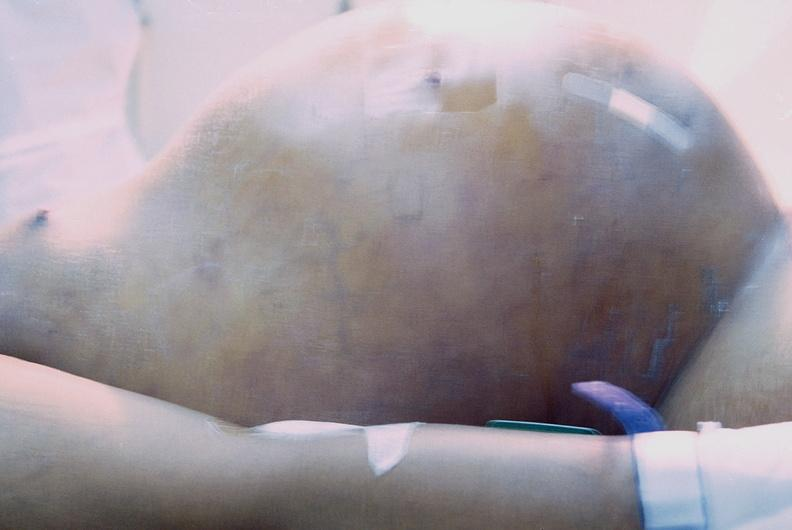what is present?
Answer the question using a single word or phrase. Abdomen 